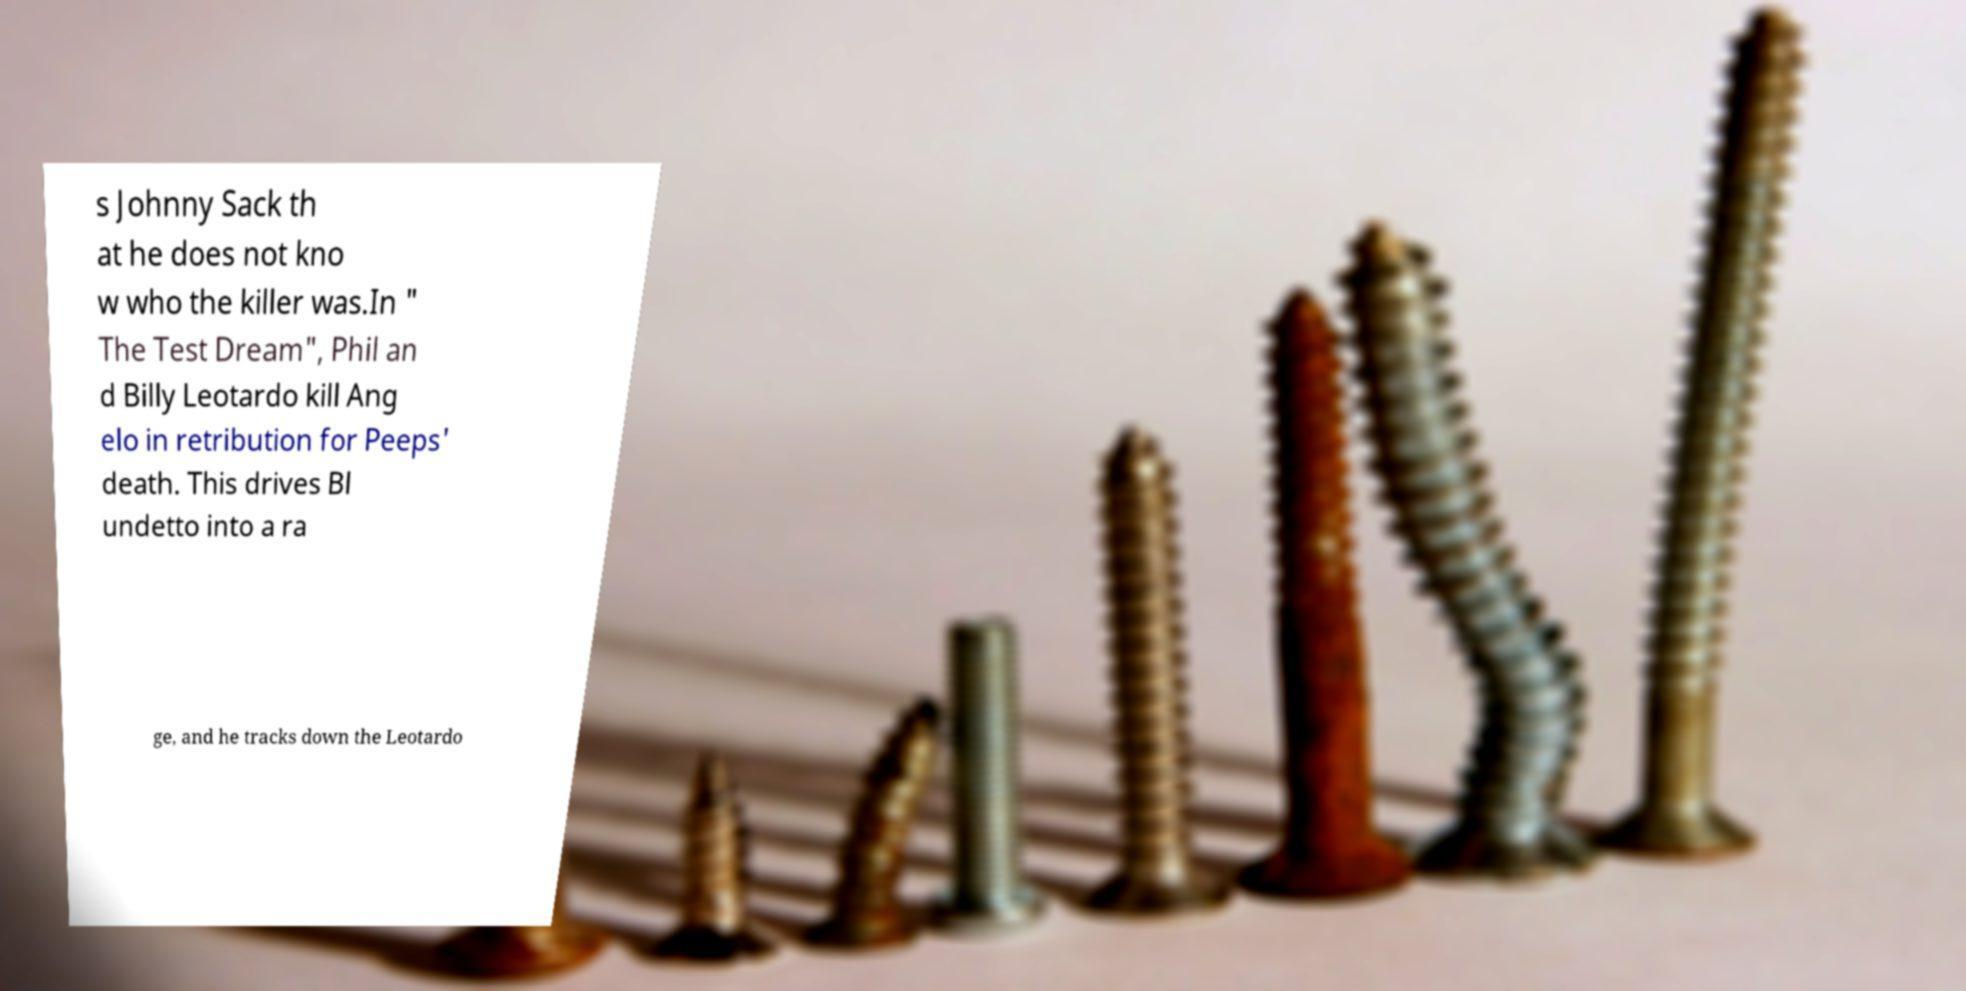For documentation purposes, I need the text within this image transcribed. Could you provide that? s Johnny Sack th at he does not kno w who the killer was.In " The Test Dream", Phil an d Billy Leotardo kill Ang elo in retribution for Peeps' death. This drives Bl undetto into a ra ge, and he tracks down the Leotardo 